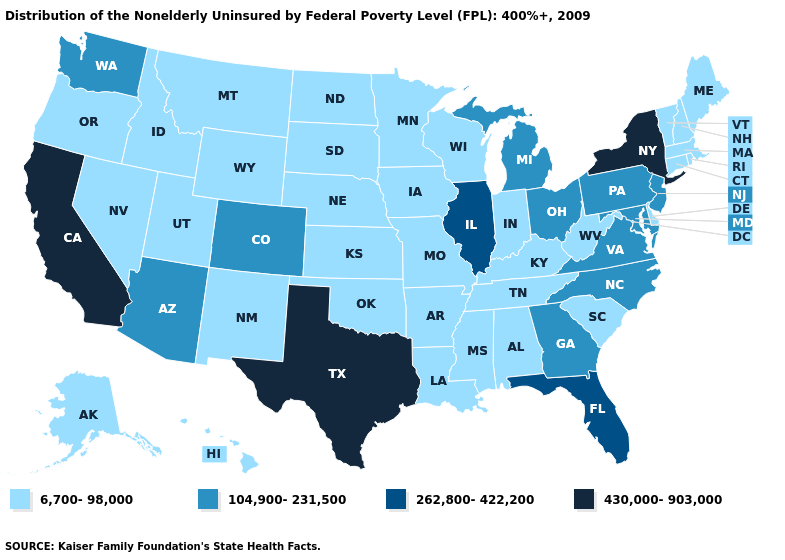What is the value of Delaware?
Be succinct. 6,700-98,000. Name the states that have a value in the range 262,800-422,200?
Concise answer only. Florida, Illinois. Which states have the lowest value in the USA?
Short answer required. Alabama, Alaska, Arkansas, Connecticut, Delaware, Hawaii, Idaho, Indiana, Iowa, Kansas, Kentucky, Louisiana, Maine, Massachusetts, Minnesota, Mississippi, Missouri, Montana, Nebraska, Nevada, New Hampshire, New Mexico, North Dakota, Oklahoma, Oregon, Rhode Island, South Carolina, South Dakota, Tennessee, Utah, Vermont, West Virginia, Wisconsin, Wyoming. Name the states that have a value in the range 262,800-422,200?
Keep it brief. Florida, Illinois. Among the states that border Rhode Island , which have the highest value?
Keep it brief. Connecticut, Massachusetts. Among the states that border Delaware , which have the lowest value?
Keep it brief. Maryland, New Jersey, Pennsylvania. What is the highest value in states that border Utah?
Be succinct. 104,900-231,500. Name the states that have a value in the range 430,000-903,000?
Answer briefly. California, New York, Texas. What is the highest value in states that border Wisconsin?
Short answer required. 262,800-422,200. Name the states that have a value in the range 430,000-903,000?
Quick response, please. California, New York, Texas. Which states have the lowest value in the South?
Write a very short answer. Alabama, Arkansas, Delaware, Kentucky, Louisiana, Mississippi, Oklahoma, South Carolina, Tennessee, West Virginia. Does Georgia have the lowest value in the USA?
Be succinct. No. Name the states that have a value in the range 262,800-422,200?
Keep it brief. Florida, Illinois. Does the map have missing data?
Short answer required. No. 